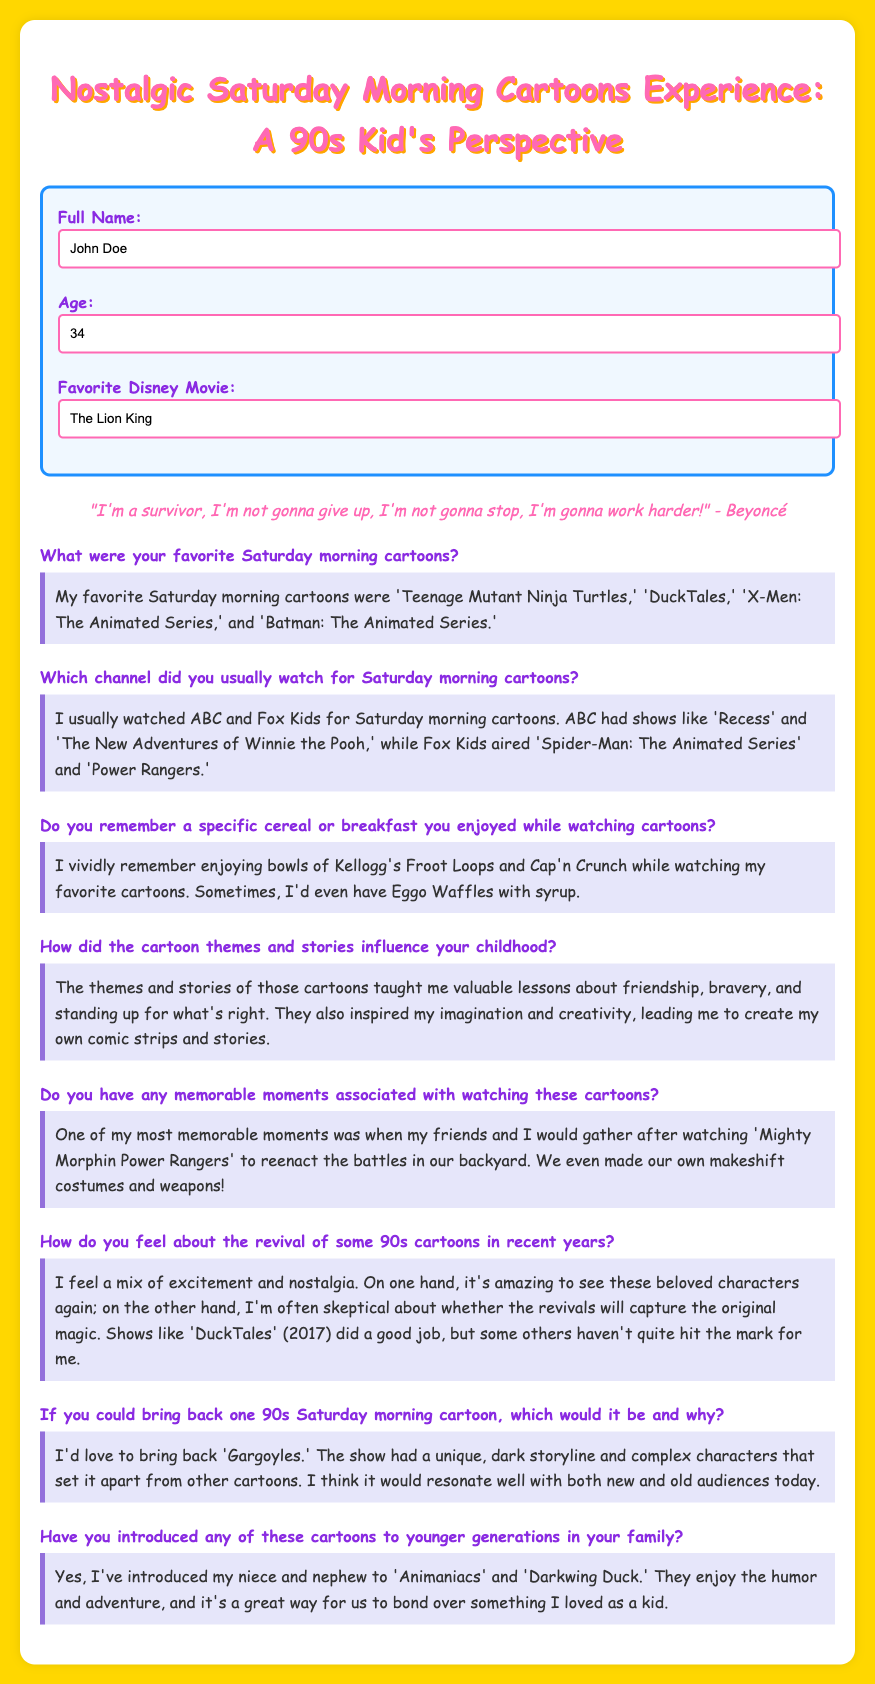What is the full name of the survey participant? The full name of the survey participant is mentioned in the document.
Answer: John Doe How old is the survey participant? The age of the survey participant is provided in the form.
Answer: 34 What is the favorite Disney movie listed in the survey? The favorite Disney movie is specified in the document under a specific question.
Answer: The Lion King Which Saturday morning cartoon is mentioned as a favorite? Multiple favorite cartoons are listed, but one is specifically mentioned in the response.
Answer: Teenage Mutant Ninja Turtles What breakfast cereal is recalled by the participant? The participant remembers a specific breakfast cereal mentioned in the document.
Answer: Froot Loops What feelings does the participant express about the revival of 90s cartoons? The participant shares their feelings regarding the revival of some cartoons, which is summarized in the response.
Answer: Excitement and nostalgia Which cartoon did the participant want to bring back? The preferred cartoon to revive is stated in the document.
Answer: Gargoyles What activity did the participant do with friends after watching Power Rangers? The document describes a specific activity related to a cartoon that the participant did with friends.
Answer: Reenact battles 